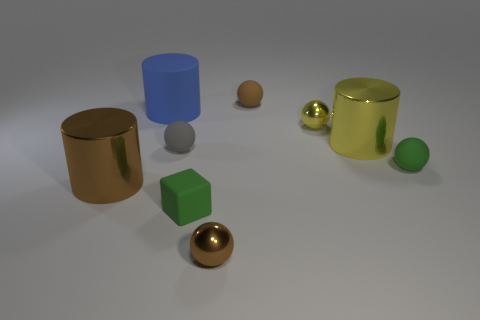How would you describe the mood or atmosphere conveyed by the image? The image conveys a calm and serene atmosphere, potentially used for analyzing shape and form in a controlled environment. The orderly arrangement and the simplicity of the objects, combined with the soft lighting, create a sense of balance and tranquility. 